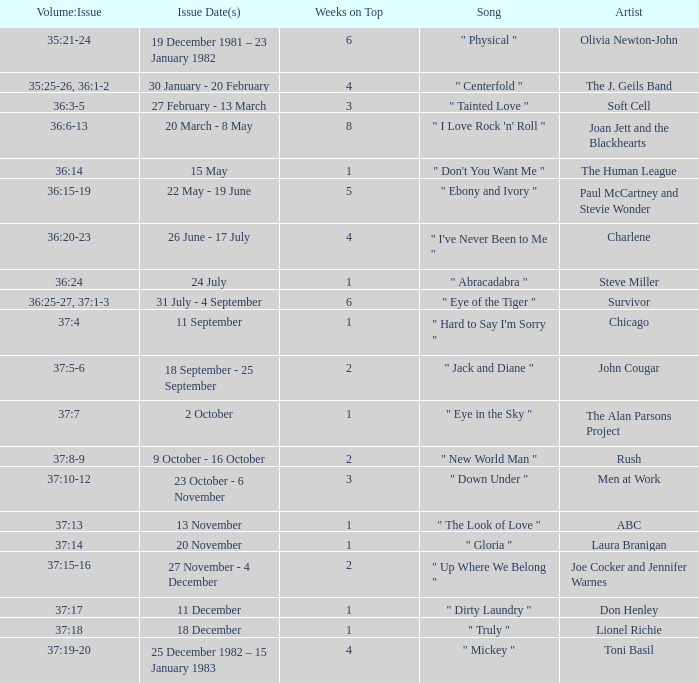Can you give me this table as a dict? {'header': ['Volume:Issue', 'Issue Date(s)', 'Weeks on Top', 'Song', 'Artist'], 'rows': [['35:21-24', '19 December 1981 – 23 January 1982', '6', '" Physical "', 'Olivia Newton-John'], ['35:25-26, 36:1-2', '30 January - 20 February', '4', '" Centerfold "', 'The J. Geils Band'], ['36:3-5', '27 February - 13 March', '3', '" Tainted Love "', 'Soft Cell'], ['36:6-13', '20 March - 8 May', '8', '" I Love Rock \'n\' Roll "', 'Joan Jett and the Blackhearts'], ['36:14', '15 May', '1', '" Don\'t You Want Me "', 'The Human League'], ['36:15-19', '22 May - 19 June', '5', '" Ebony and Ivory "', 'Paul McCartney and Stevie Wonder'], ['36:20-23', '26 June - 17 July', '4', '" I\'ve Never Been to Me "', 'Charlene'], ['36:24', '24 July', '1', '" Abracadabra "', 'Steve Miller'], ['36:25-27, 37:1-3', '31 July - 4 September', '6', '" Eye of the Tiger "', 'Survivor'], ['37:4', '11 September', '1', '" Hard to Say I\'m Sorry "', 'Chicago'], ['37:5-6', '18 September - 25 September', '2', '" Jack and Diane "', 'John Cougar'], ['37:7', '2 October', '1', '" Eye in the Sky "', 'The Alan Parsons Project'], ['37:8-9', '9 October - 16 October', '2', '" New World Man "', 'Rush'], ['37:10-12', '23 October - 6 November', '3', '" Down Under "', 'Men at Work'], ['37:13', '13 November', '1', '" The Look of Love "', 'ABC'], ['37:14', '20 November', '1', '" Gloria "', 'Laura Branigan'], ['37:15-16', '27 November - 4 December', '2', '" Up Where We Belong "', 'Joe Cocker and Jennifer Warnes'], ['37:17', '11 December', '1', '" Dirty Laundry "', 'Don Henley'], ['37:18', '18 December', '1', '" Truly "', 'Lionel Richie'], ['37:19-20', '25 December 1982 – 15 January 1983', '4', '" Mickey "', 'Toni Basil']]} Which weeks on top feature an issue date(s) of 20 november? 1.0. 